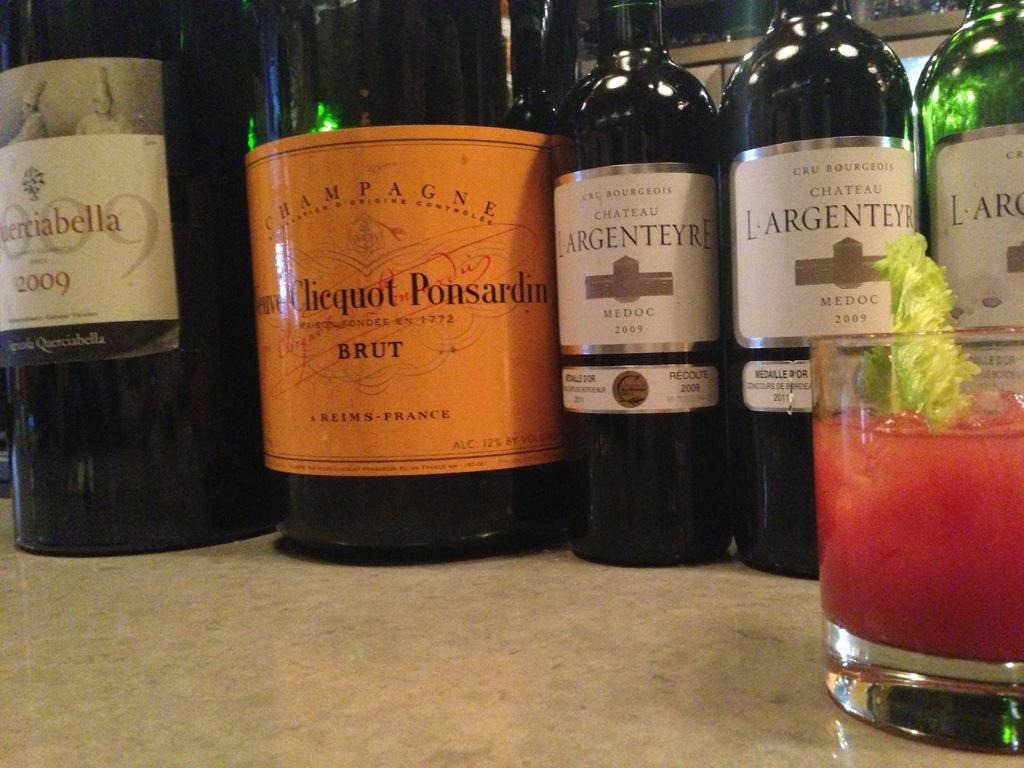<image>
Share a concise interpretation of the image provided. Bottles line a counter with one from France with an orange label. 